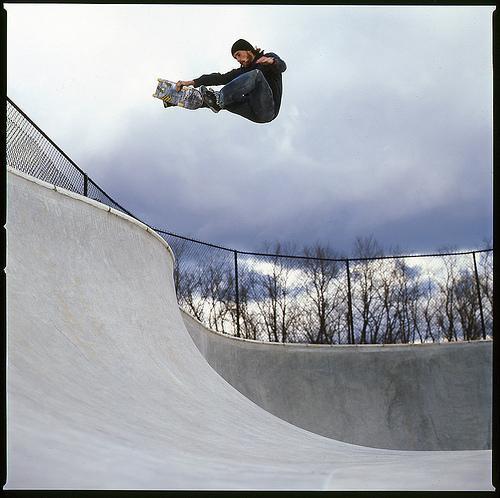How many ski lifts are to the right of the man in the yellow coat?
Give a very brief answer. 0. 